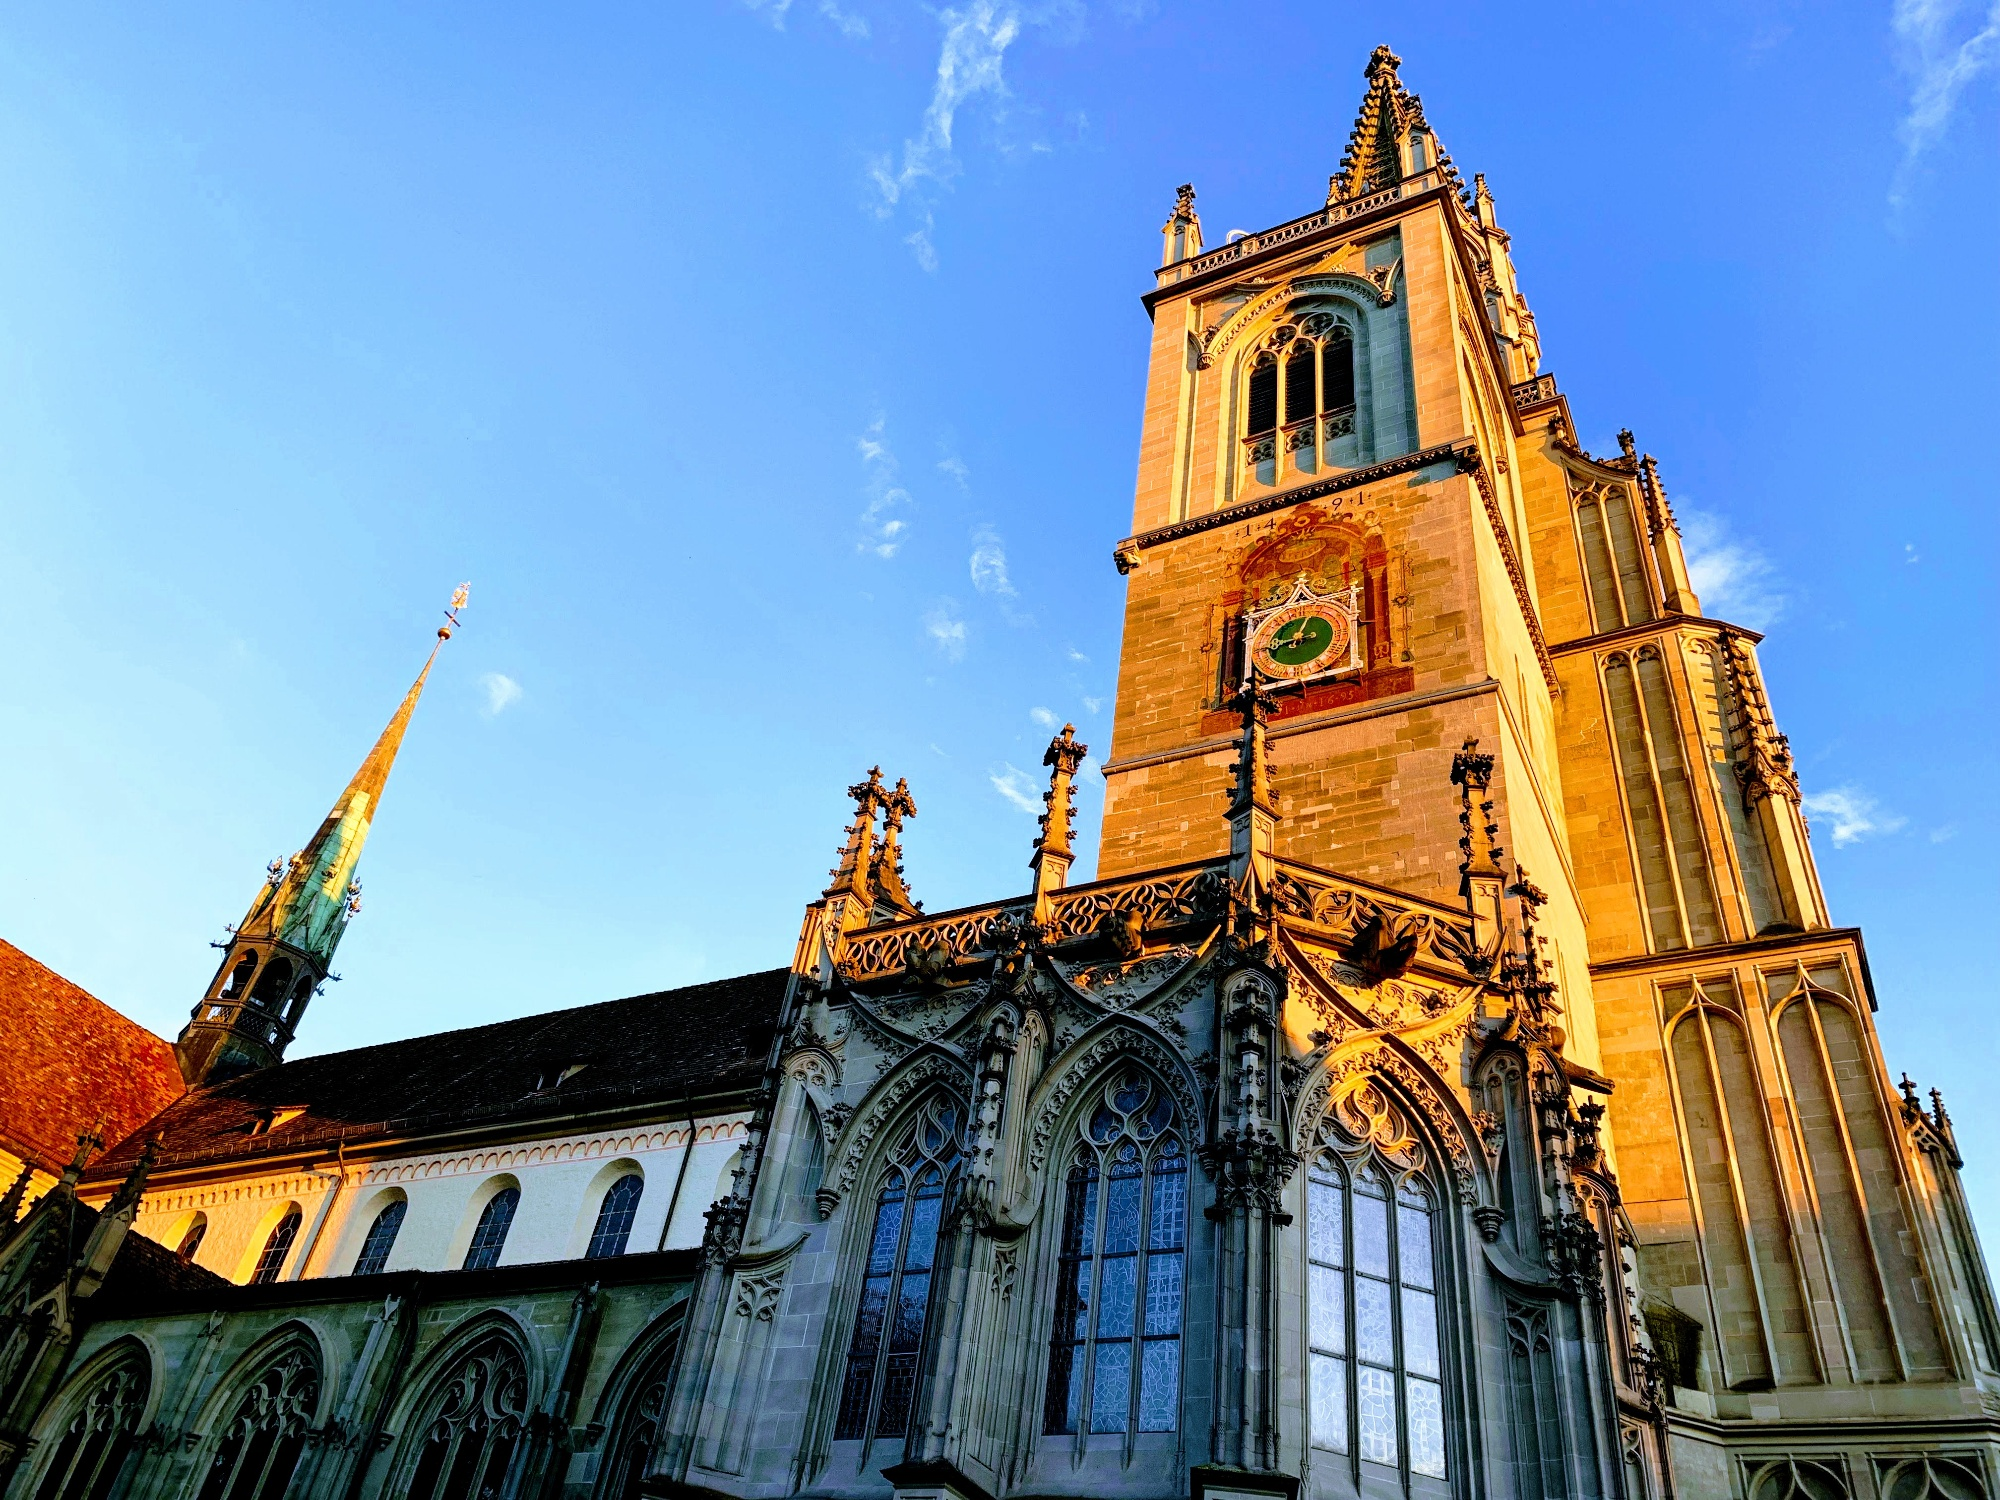Imagine a fantastical story set in this cathedral. Long ago, in the heart of Konstanz Minster, there was a legend of a mystical artifact hidden within the cathedral's tallest spire. This artifact, said to grant immense knowledge and power, was protected by ancient guardians only visible during the full moon. One stormy night, a young scholar named Elara discovered a hidden manuscript in the cathedral’s crypt. The manuscript revealed clues leading to the artifact’s location. Braving the relentless storm and the maze of secret passages, Elara found herself at the top of the spire, where the artifact lay surrounded by a brilliant glow. As she reached out to grasp it, the guardians appeared, testing her worthiness through a series of riddles. Elara’s wit and pure heart prevailed, and she unlocked the artifact’s true potential, using its power to bring prosperity and knowledge to Konstanz for generations to come. 